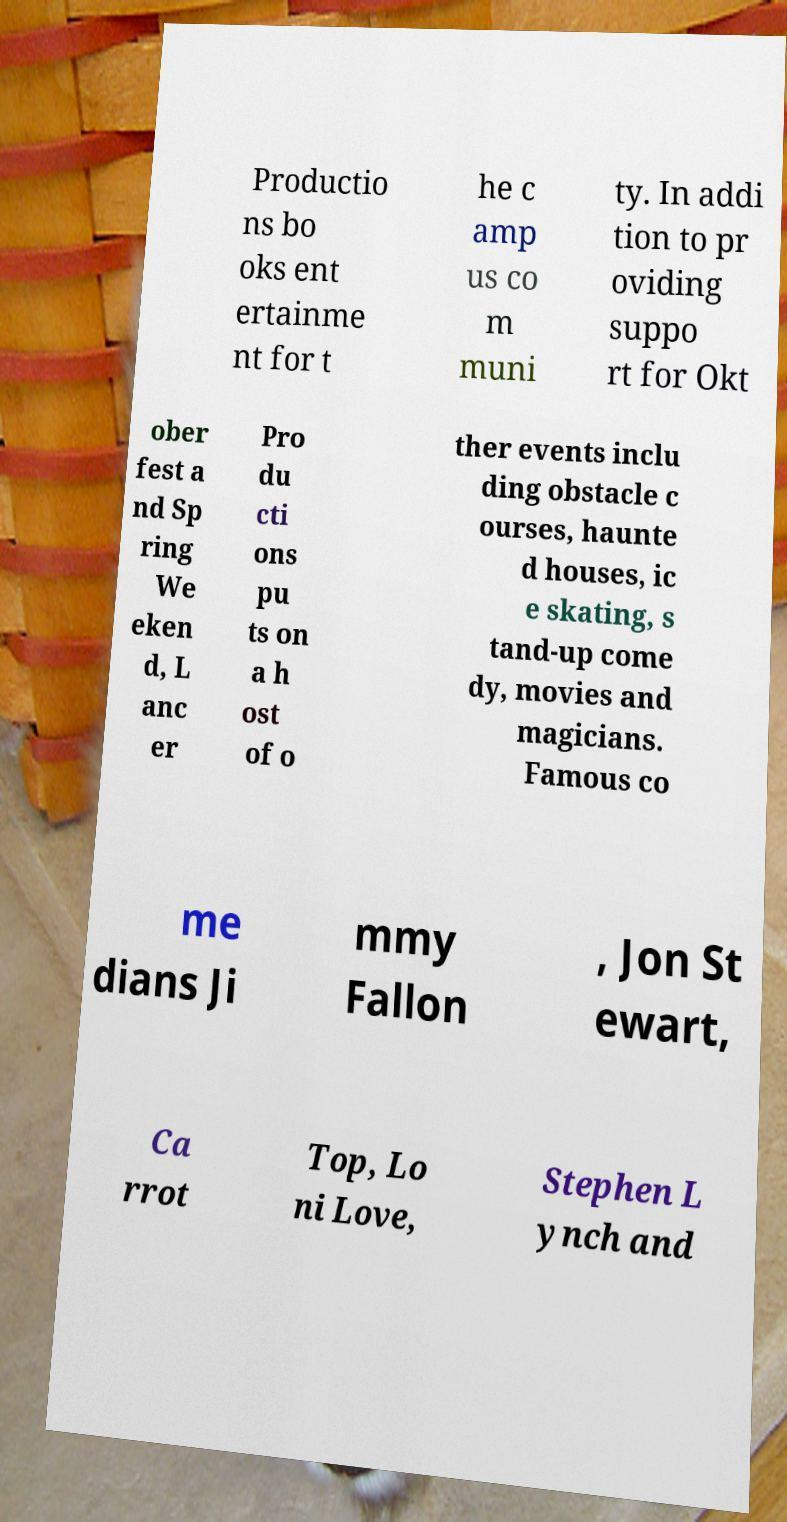Could you assist in decoding the text presented in this image and type it out clearly? Productio ns bo oks ent ertainme nt for t he c amp us co m muni ty. In addi tion to pr oviding suppo rt for Okt ober fest a nd Sp ring We eken d, L anc er Pro du cti ons pu ts on a h ost of o ther events inclu ding obstacle c ourses, haunte d houses, ic e skating, s tand-up come dy, movies and magicians. Famous co me dians Ji mmy Fallon , Jon St ewart, Ca rrot Top, Lo ni Love, Stephen L ynch and 